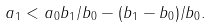<formula> <loc_0><loc_0><loc_500><loc_500>a _ { 1 } < a _ { 0 } b _ { 1 } / b _ { 0 } - ( b _ { 1 } - b _ { 0 } ) / b _ { 0 } .</formula> 